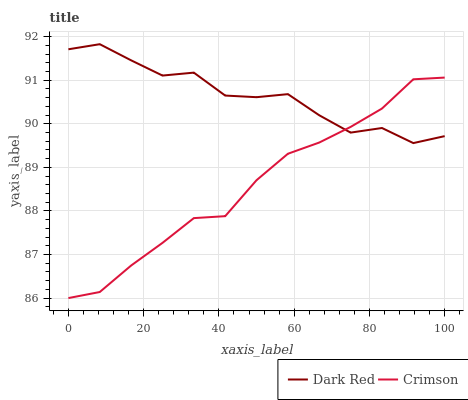Does Dark Red have the minimum area under the curve?
Answer yes or no. No. Is Dark Red the smoothest?
Answer yes or no. No. Does Dark Red have the lowest value?
Answer yes or no. No. 